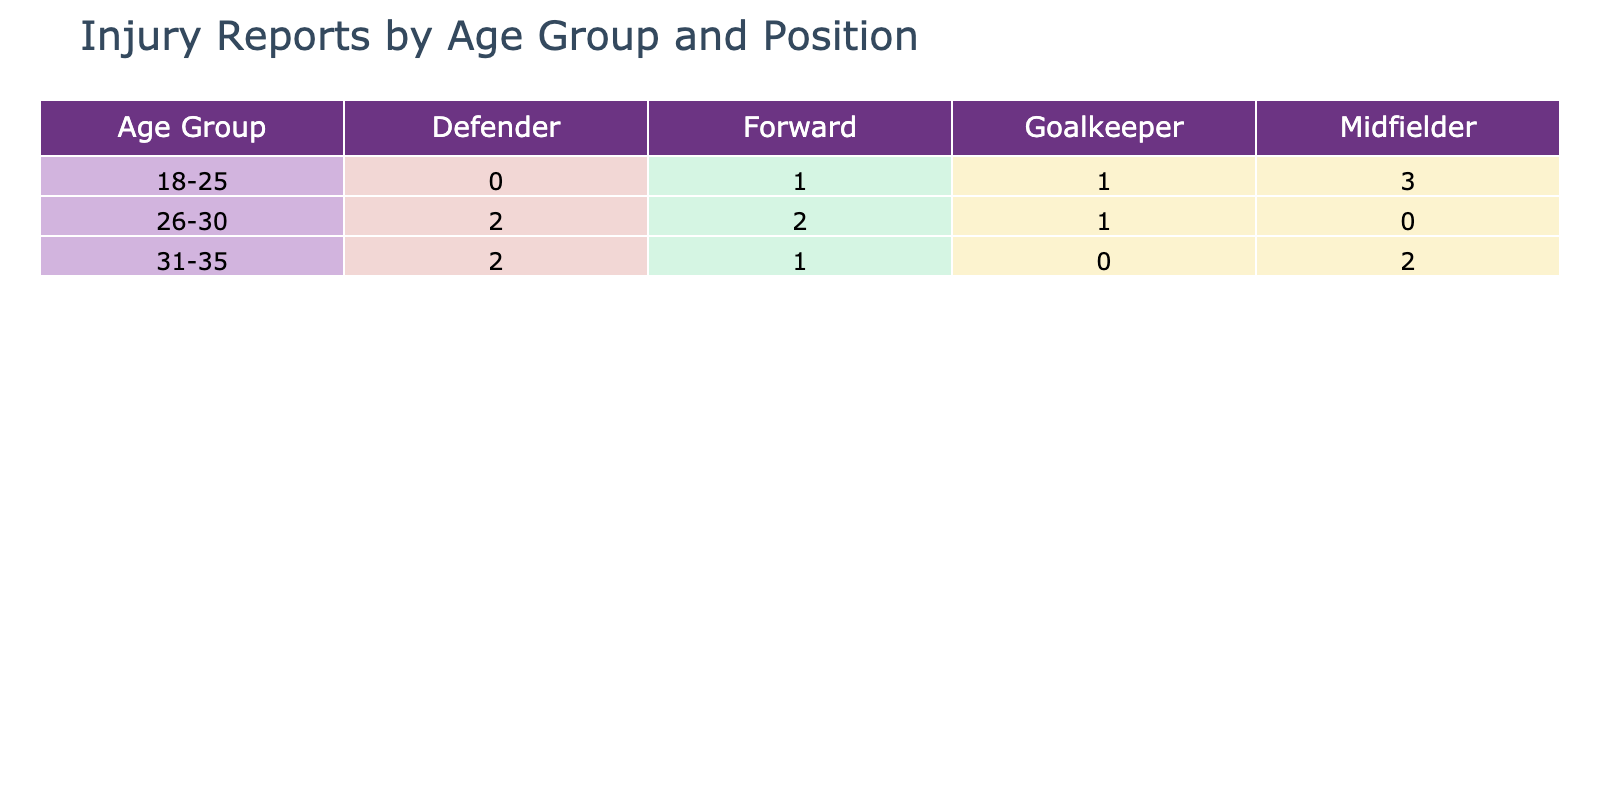What is the total number of injuries reported for the age group 26-30? In the age group 26-30, there are 3 reported injuries: 1 for Forward (Thigh Contusion), 1 for Midfielder (Achilles Tendonitis), and 1 for Defender (Calf Strain). Therefore, the total is 3 injuries.
Answer: 3 Which position type has the highest number of reported injuries in the 31-35 age group? In the age group 31-35, the reported injuries are: 1 for Forward (Groin Pull), 1 for Midfielder (Hip Flexor Injury), and 1 for Defender (Back Injury). Each position type has 1 injury, so there is a tie among them.
Answer: Tie (1 for each position) How many Midfielders are reported to have injuries? By checking the table, Midfielders have the following reported injuries: Hamstring Tear, Concussion, Achilles Tendonitis, Hip Flexor Injury, and Minor Sprain. There are 5 injuries reported for Midfielders.
Answer: 5 Are there any injuries reported for players aged 21? The player aged 21, reported to have an injury, is categorized under Midfielder with a Minor Sprain. Thus, there is an injury reported for this age.
Answer: Yes What is the difference in the number of injuries reported between Forwards and Defenders? Forwards have a total of 4 reported injuries: Ankle Sprain, Groin Pull, Thigh Contusion, and Foot Fracture. Defenders have a total of 4 reported injuries: Knee Injury, Calf Strain, Back Injury, and Ankle Fracture. Therefore, the difference is 0.
Answer: 0 Which age group has the highest number of reported injuries in total? To determine this, we sum the injuries reported in each age group: 18-25 has 3 (1 Forward, 2 Midfielders), 26-30 has 3 (3 types of positions), 31-35 has 3 (1 for each position as well), and 36+ has 2 (combined total). Each group ties at 3, therefore none has the highest.
Answer: Tie (3 in each of the first three age groups) What specific injury was reported for the oldest player age group (36 and above)? In the 36 and above age group, the injuries reported are Ankle Fracture and Back Injury. Hence, both injuries belong to this age group.
Answer: Ankle Fracture, Back Injury Is there any position type that does not have reported injuries for the age group 18-25? In the age group 18-25, we see injuries reported for Midfielder and Forward, but there are no reported injuries for Goalkeepers or Defenders. Therefore, the answer is yes.
Answer: Yes 